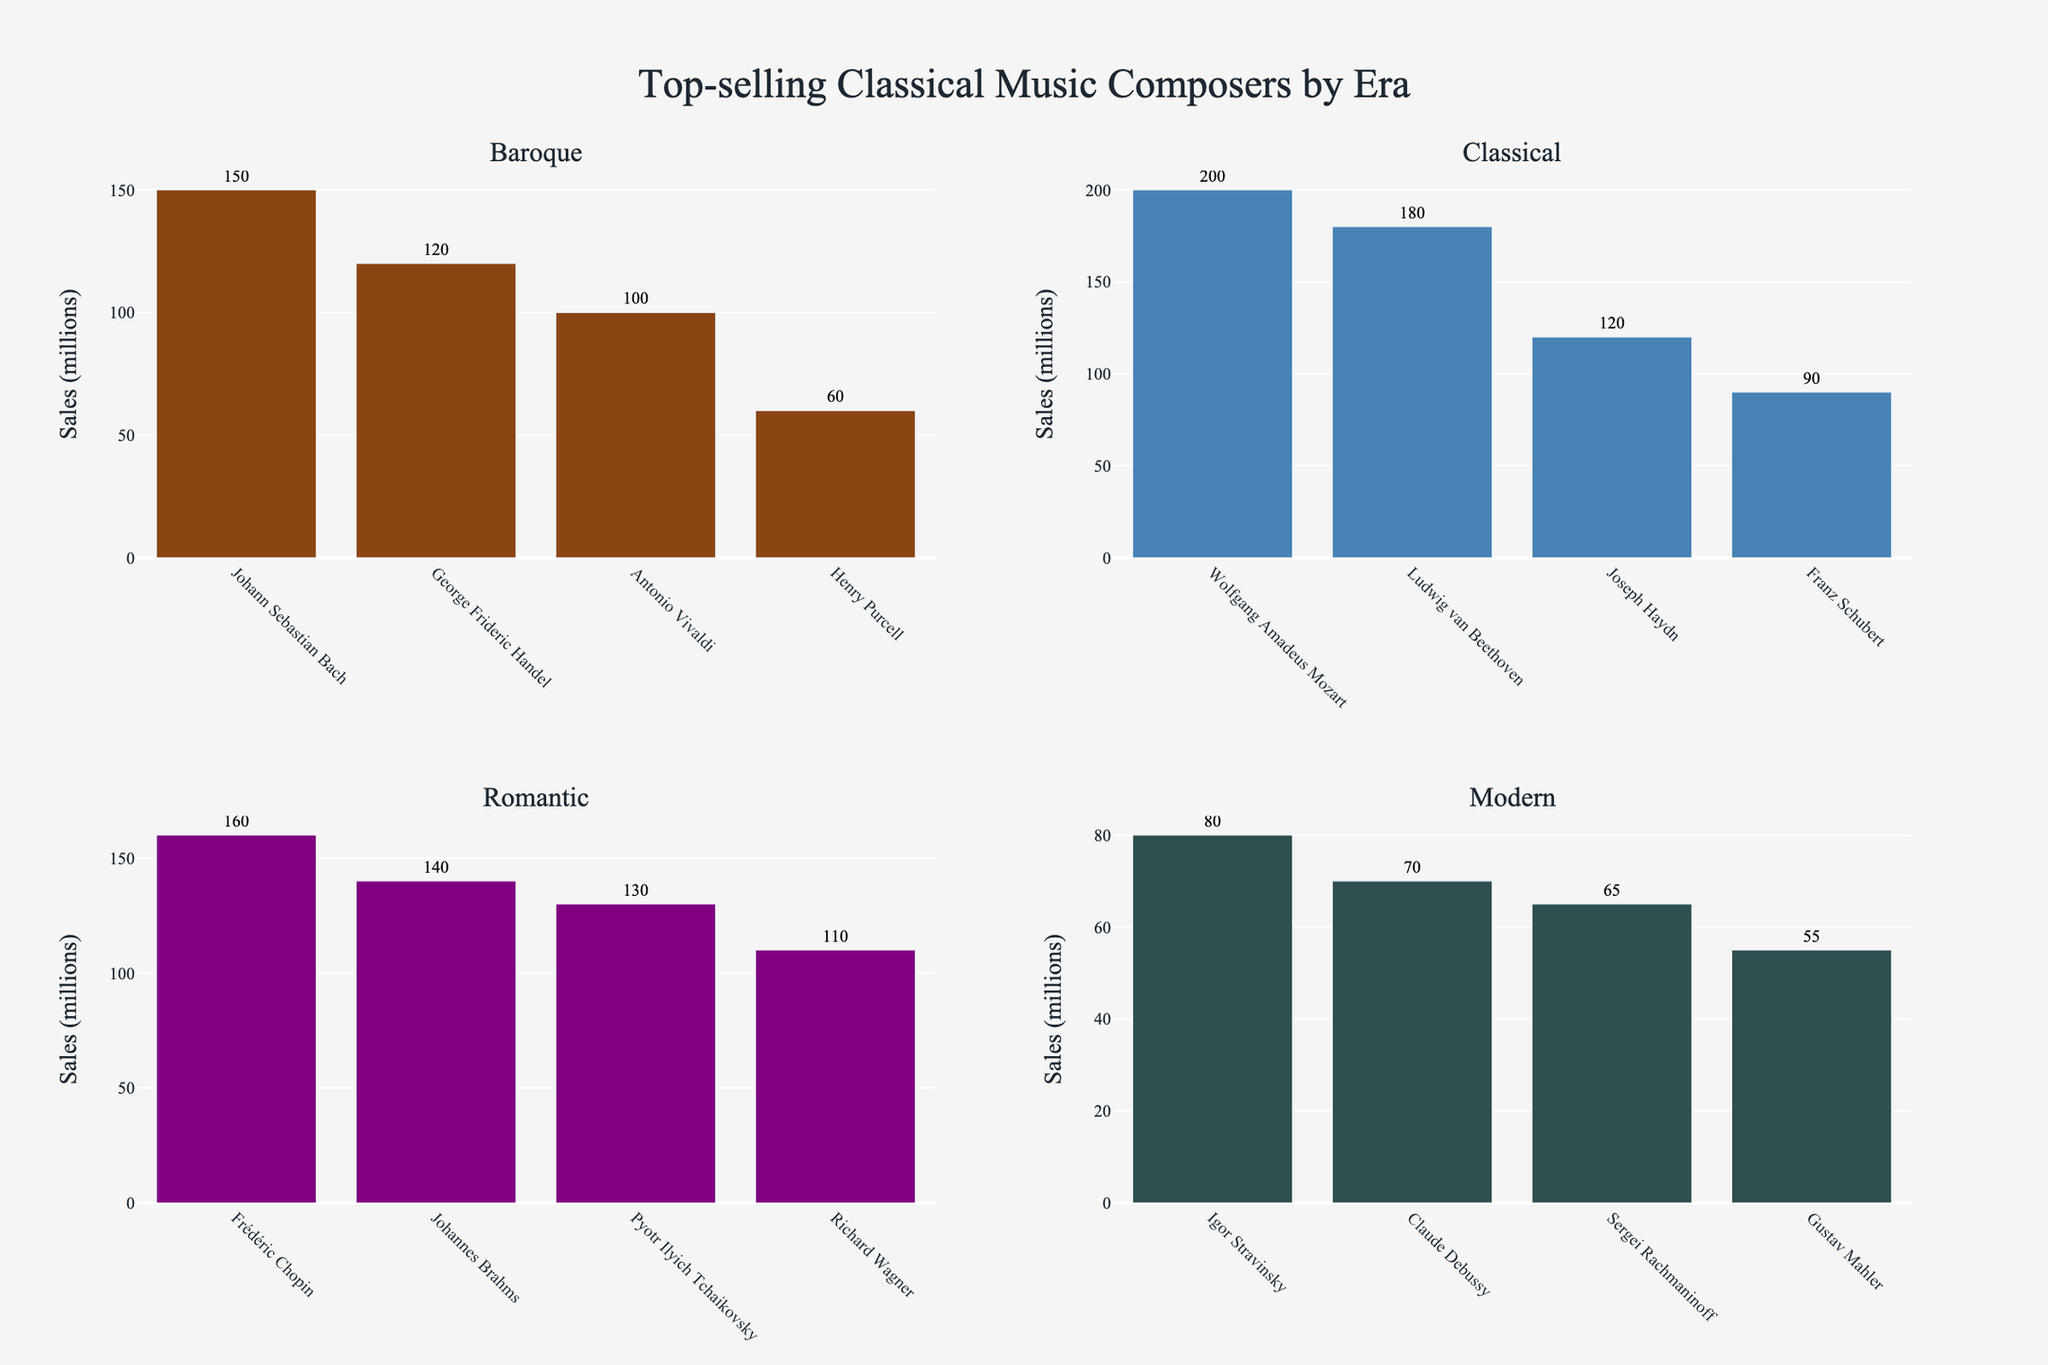What is the total sales volume of composers from the Baroque era? Sum the sales volumes of all Baroque composers: Johann Sebastian Bach (150), George Frideric Handel (120), Antonio Vivaldi (100), Henry Purcell (60). Thus, 150 + 120 + 100 + 60 = 430 million.
Answer: 430 million Who is the top-selling composer in the Classical era and what are his sales? Refer to the Classical era section. Wolfgang Amadeus Mozart has the highest sales with 200 million.
Answer: Wolfgang Amadeus Mozart, 200 million How much greater are the sales of the top-selling Romantic composer compared to the top-selling Modern composer? Identify the top-selling composers from the Romantic and Modern eras. Frédéric Chopin (Romantic) has 160 million; Igor Stravinsky (Modern) has 80 million. Calculate the difference: 160 - 80 = 80.
Answer: 80 million What is the average sales volume of composers from the Romantic era? Sum the sales volumes of Romantic composers (Chopin: 160, Brahms: 140, Tchaikovsky: 130, Wagner: 110), then divide by the number of composers (4). Thus, (160+140+130+110)/4 = 135 million.
Answer: 135 million Which composer has the lowest sales in the Baroque era and how much are they? Refer to the Baroque era section. Henry Purcell has the lowest sales with 60 million.
Answer: Henry Purcell, 60 million Is the sales volume of Ludwig van Beethoven greater than the combined sales of Henry Purcell and Claude Debussy? Ludwig van Beethoven has sales of 180 million. Combine the sales of Henry Purcell (60 million) and Claude Debussy (70 million): 60 + 70 = 130 million. Since 180 > 130, Beethoven's sales are higher.
Answer: Yes What is the total number of sales of the composers in the bottom row of the figure (Modern era)? Sum the sales volumes of the Modern era composers: Igor Stravinsky (80), Claude Debussy (70), Sergei Rachmaninoff (65), Gustav Mahler (55). Thus, 80 + 70 + 65 + 55 = 270 million.
Answer: 270 million Which era has the highest total sales volume? Sum the total sales volumes for each era: Baroque (430 million), Classical (590 million), Romantic (540 million), Modern (270 million). The Classical era has the highest total with 590 million.
Answer: Classical How much more are the sales of Wolfgang Amadeus Mozart compared to Antonio Vivaldi? Wolfgang Amadeus Mozart has sales of 200 million; Antonio Vivaldi has sales of 100 million. Calculate the difference: 200 - 100 = 100.
Answer: 100 million 